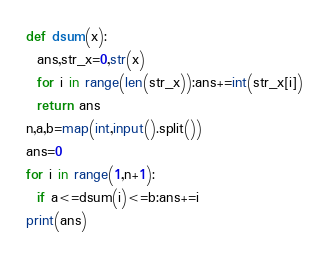Convert code to text. <code><loc_0><loc_0><loc_500><loc_500><_Python_>def dsum(x):
  ans,str_x=0,str(x)
  for i in range(len(str_x)):ans+=int(str_x[i])
  return ans
n,a,b=map(int,input().split())
ans=0
for i in range(1,n+1):
  if a<=dsum(i)<=b:ans+=i
print(ans)</code> 